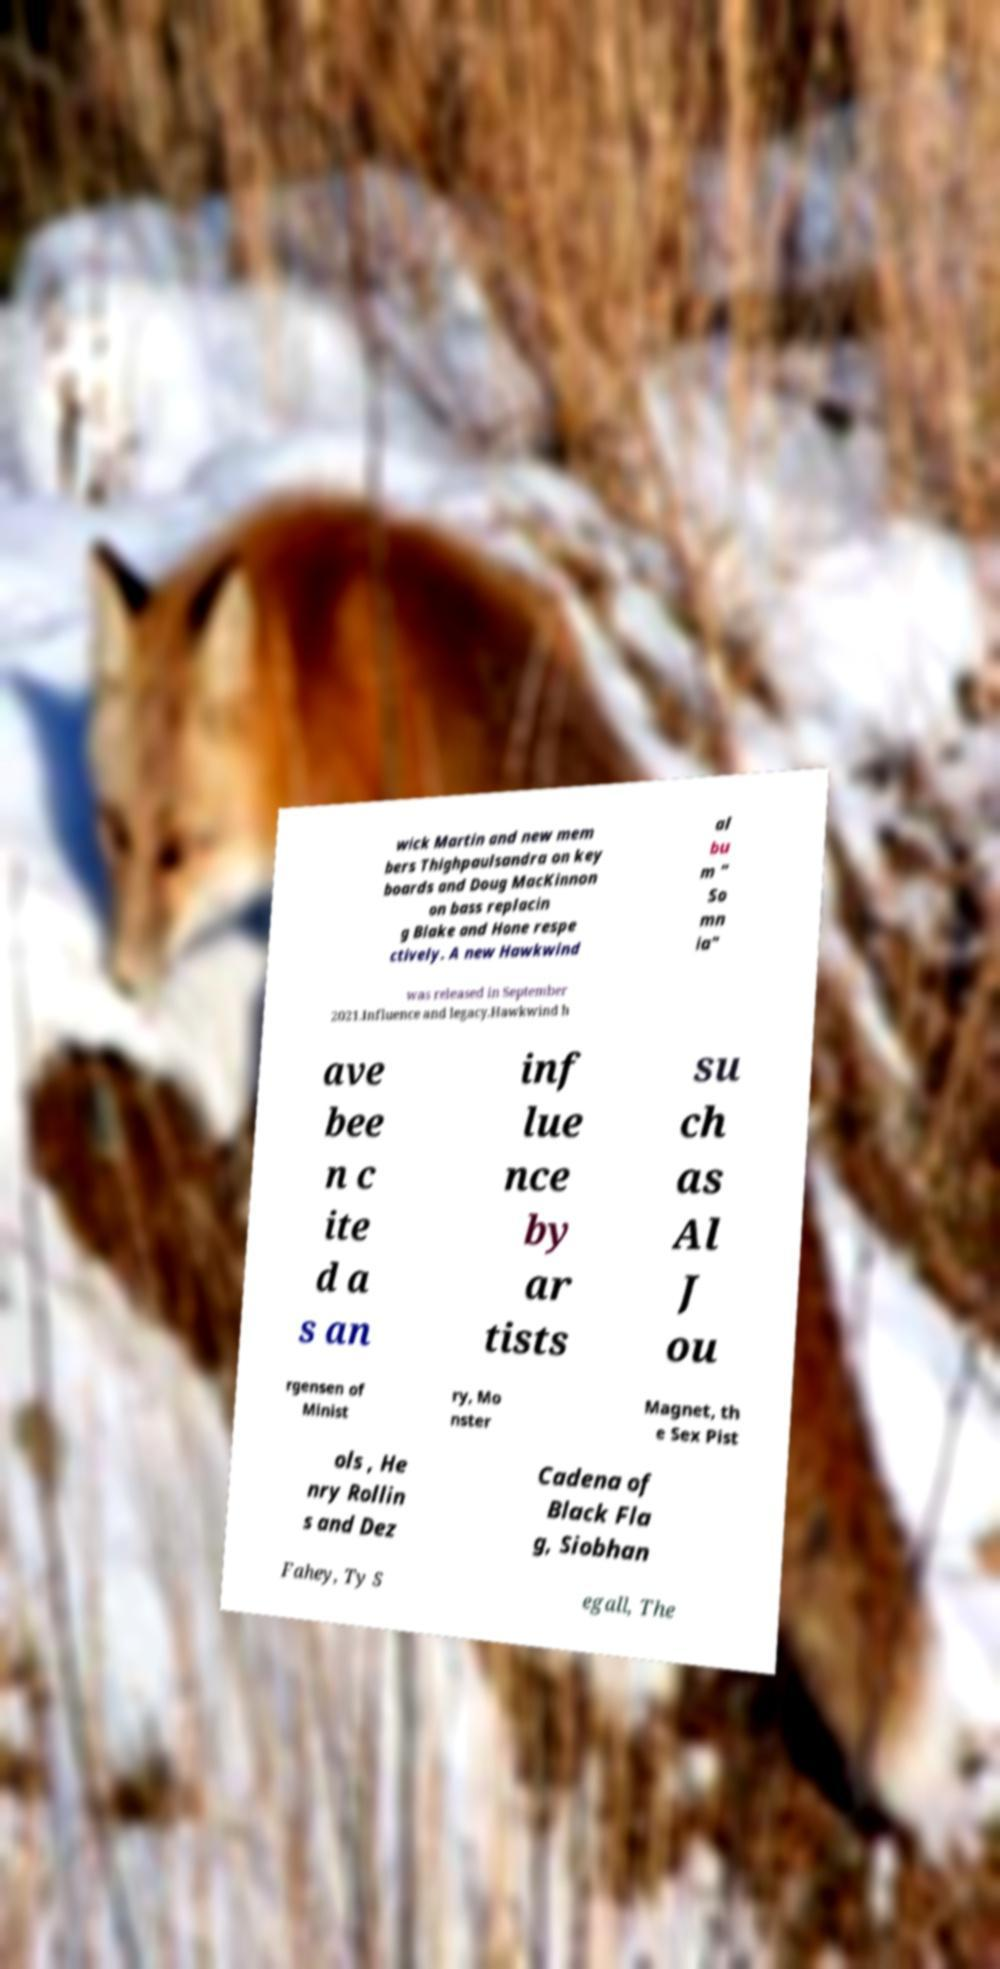I need the written content from this picture converted into text. Can you do that? wick Martin and new mem bers Thighpaulsandra on key boards and Doug MacKinnon on bass replacin g Blake and Hone respe ctively. A new Hawkwind al bu m " So mn ia" was released in September 2021.Influence and legacy.Hawkwind h ave bee n c ite d a s an inf lue nce by ar tists su ch as Al J ou rgensen of Minist ry, Mo nster Magnet, th e Sex Pist ols , He nry Rollin s and Dez Cadena of Black Fla g, Siobhan Fahey, Ty S egall, The 